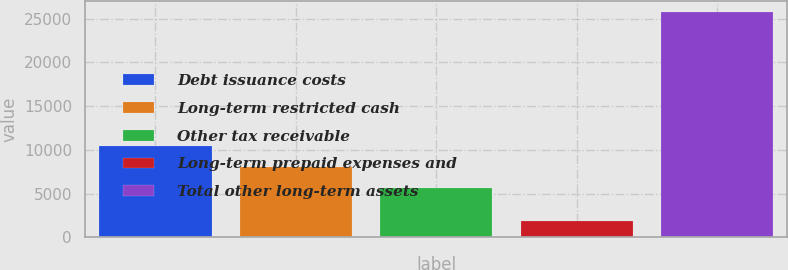<chart> <loc_0><loc_0><loc_500><loc_500><bar_chart><fcel>Debt issuance costs<fcel>Long-term restricted cash<fcel>Other tax receivable<fcel>Long-term prepaid expenses and<fcel>Total other long-term assets<nl><fcel>10445.2<fcel>8059.1<fcel>5673<fcel>1882<fcel>25743<nl></chart> 